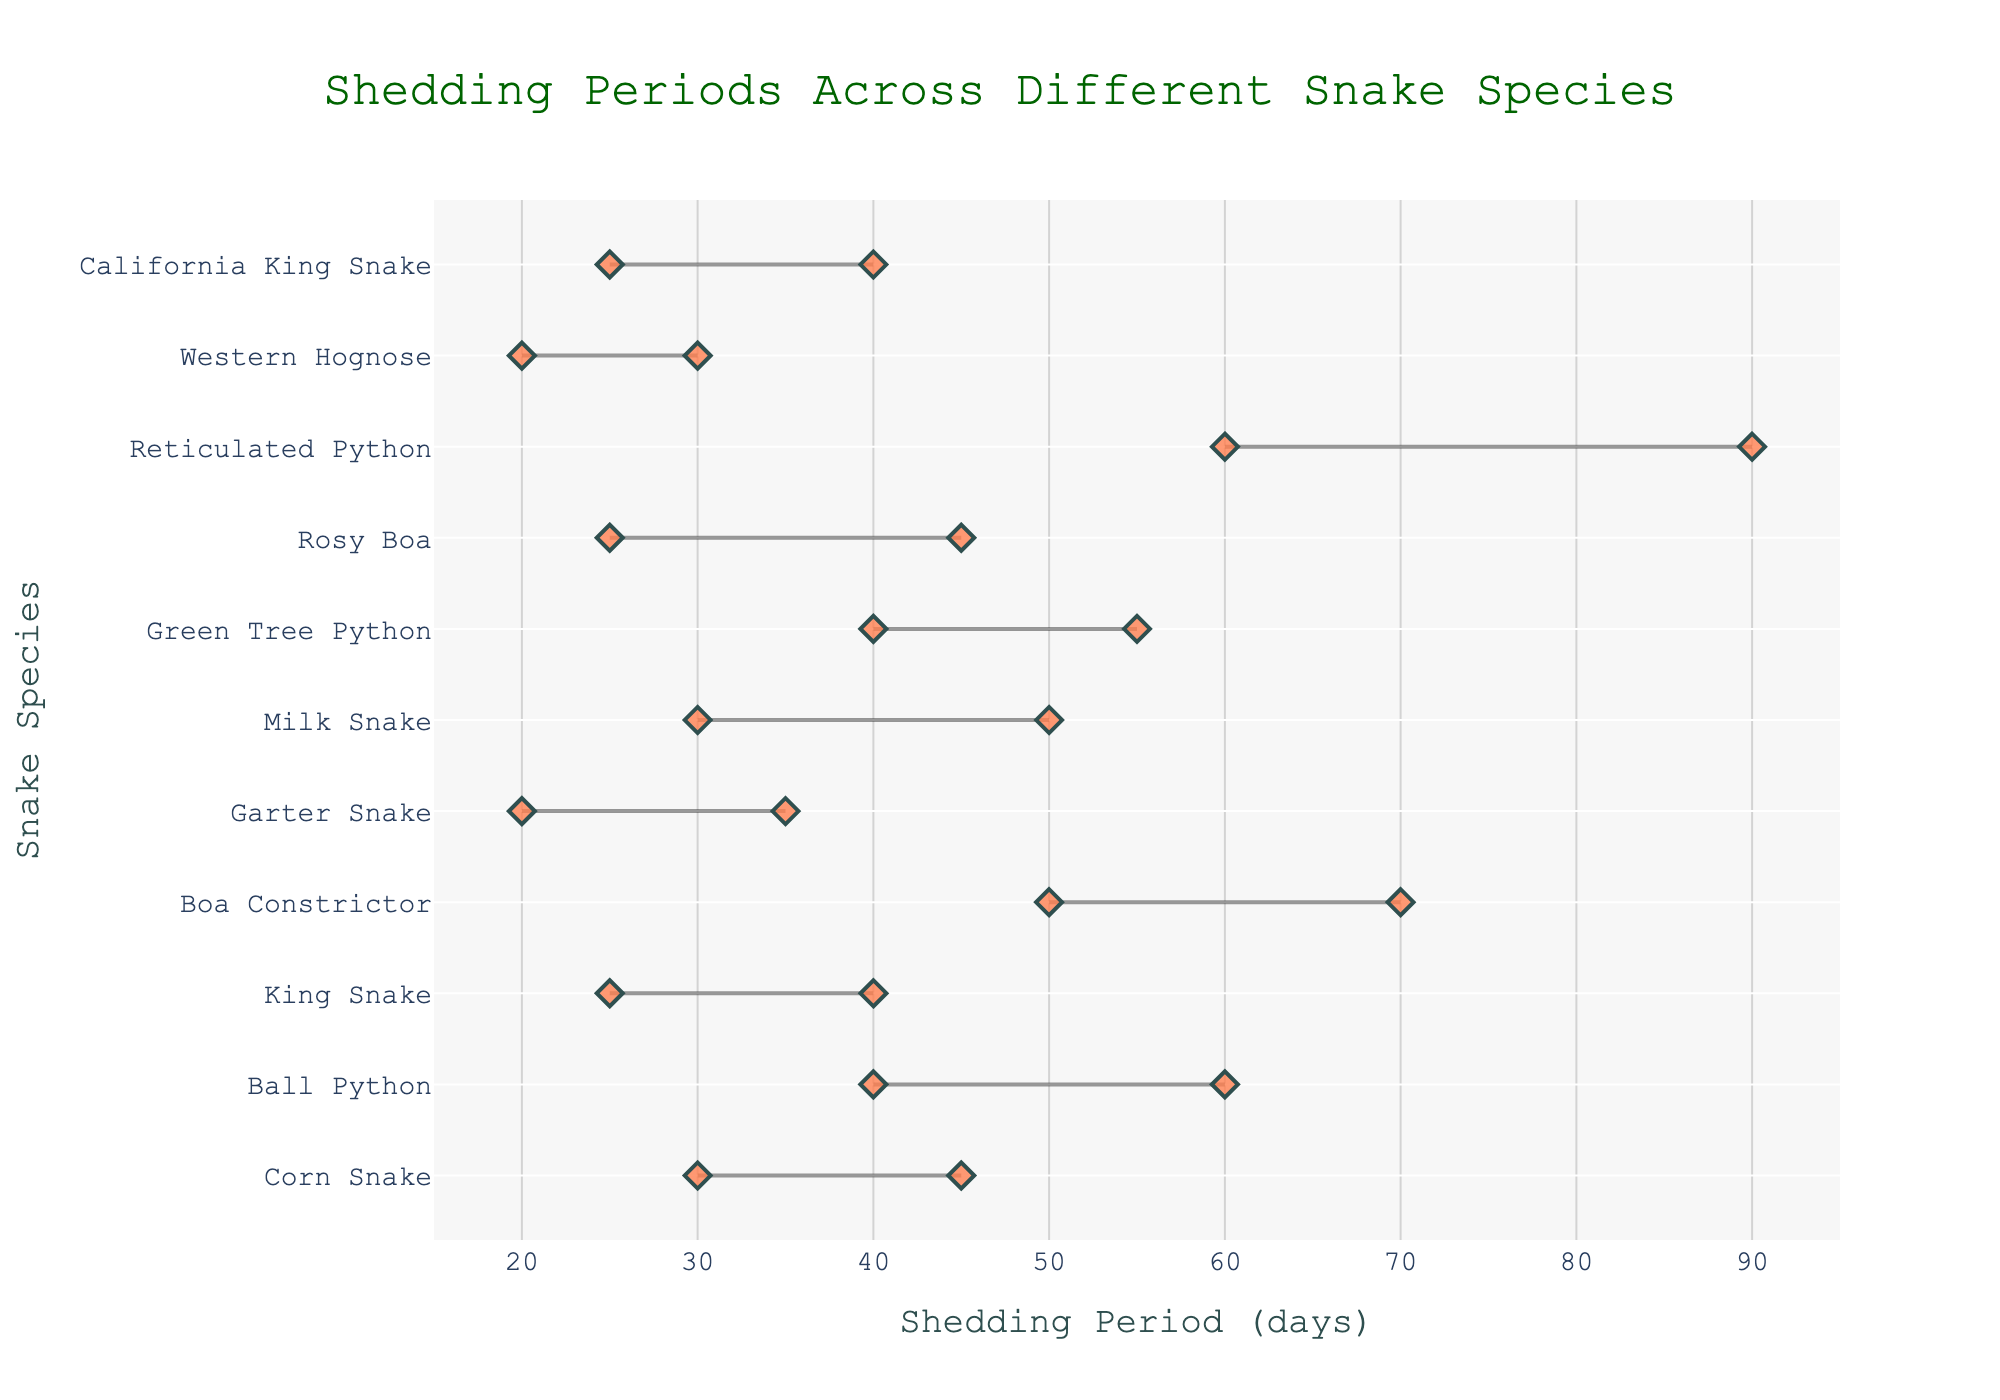What's the range of the shedding period for the Corn Snake? The shedding period for the Corn Snake spans from 30 days to 45 days. To find the range, subtract the start of the shedding period from the end (45 - 30).
Answer: 15 days What is the shortest shedding period among all snake species? The Garter Snake has the shortest shedding period. It starts shedding at 20 days and ends at 35 days.
Answer: 15 days Which pair of snake species have overlapping shedding periods? By observing the plot, we can see that the Corn Snake (30-45 days) and the Milk Snake (30-50 days) have overlapping shedding periods between 30 and 45 days.
Answer: Corn Snake and Milk Snake Which snake species has the longest interval between its start and end shedding period? The Reticulated Python has the longest interval between its shedding period start and end, spanning from 60 to 90 days (90 - 60).
Answer: Reticulated Python How does the shedding period of the Ball Python compare to the Green Tree Python? The Ball Python's shedding period is from 40 to 60 days, while the Green Tree Python's period is from 40 to 55 days. They both start shedding at 40 days, but the Ball Python continues up to 60 days, whereas the Green Tree Python ends 5 days earlier at 55 days.
Answer: Ball Python sheds longer What is the average (mean) shedding period for the Western Hognose and California King Snake? Western Hognose sheds from 20 to 30 days (average: (20+30)/2 = 25), and California King Snake sheds from 25 to 40 days (average: (25+40)/2 = 32.5). The average of these two averages is (25 + 32.5) / 2 = 28.75 days.
Answer: 28.75 days Which species has a shedding period ending closest to 50 days? The Milk Snake and Green Tree Python both have their shedding periods ending at 50 and 55 days, respectively. Out of these, the Milk Snake sheds up to 50 days, which is closest to 50.
Answer: Milk Snake Among all snake species, who starts shedding the earliest and the latest? The Garter Snake and Western Hognose start shedding the earliest at 20 days. The Reticulated Python starts shedding the latest at 60 days.
Answer: Garter Snake and Reticulated Python 